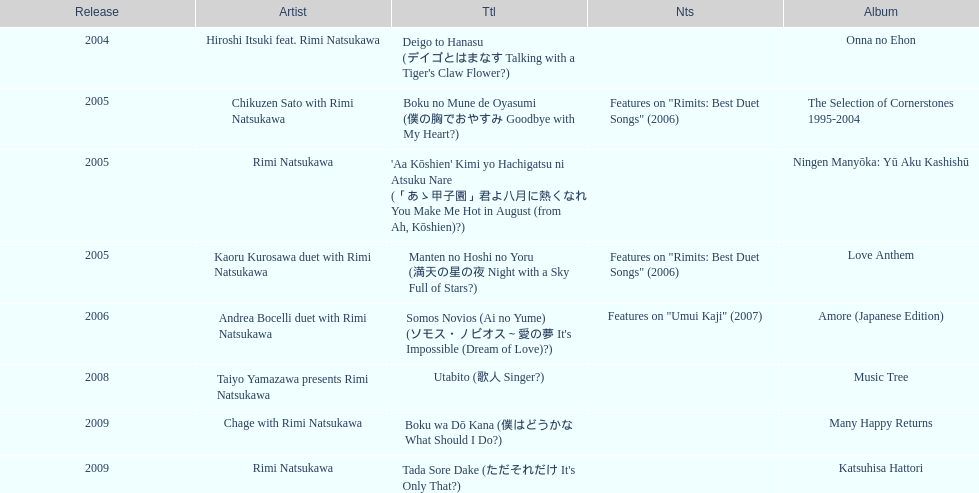What song was this artist on after utabito? Boku wa Dō Kana. 